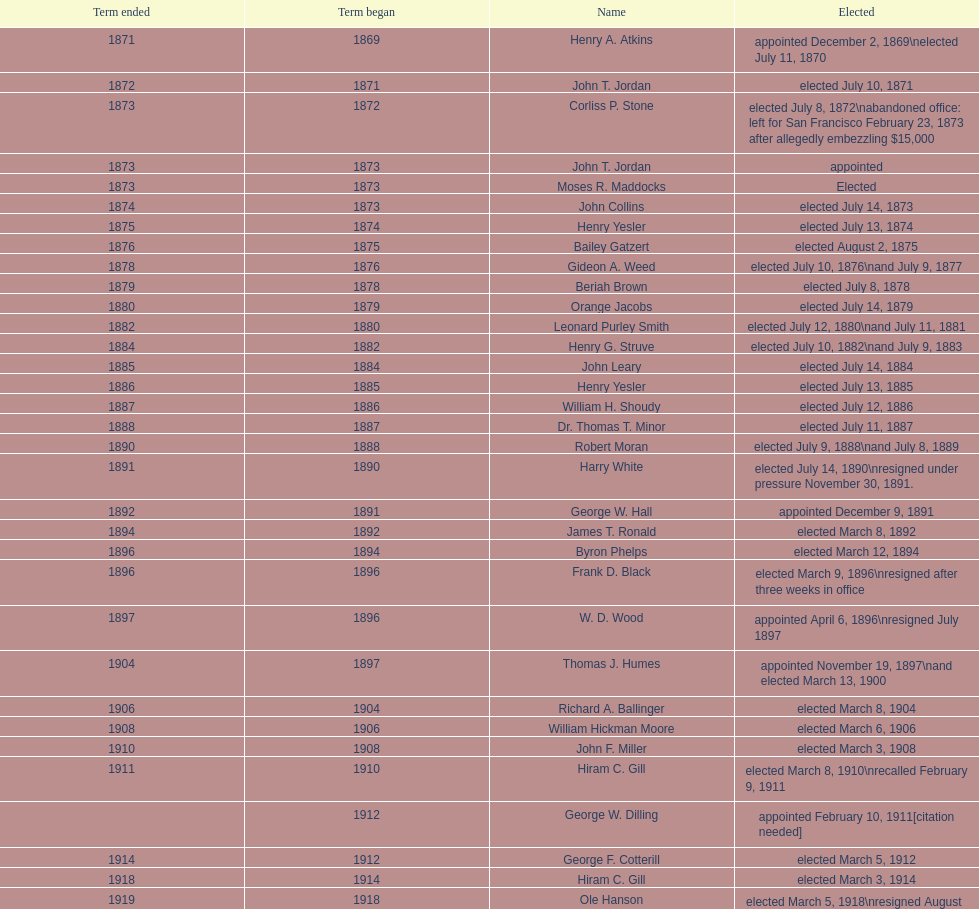What is the number of mayors with the first name of john? 6. 